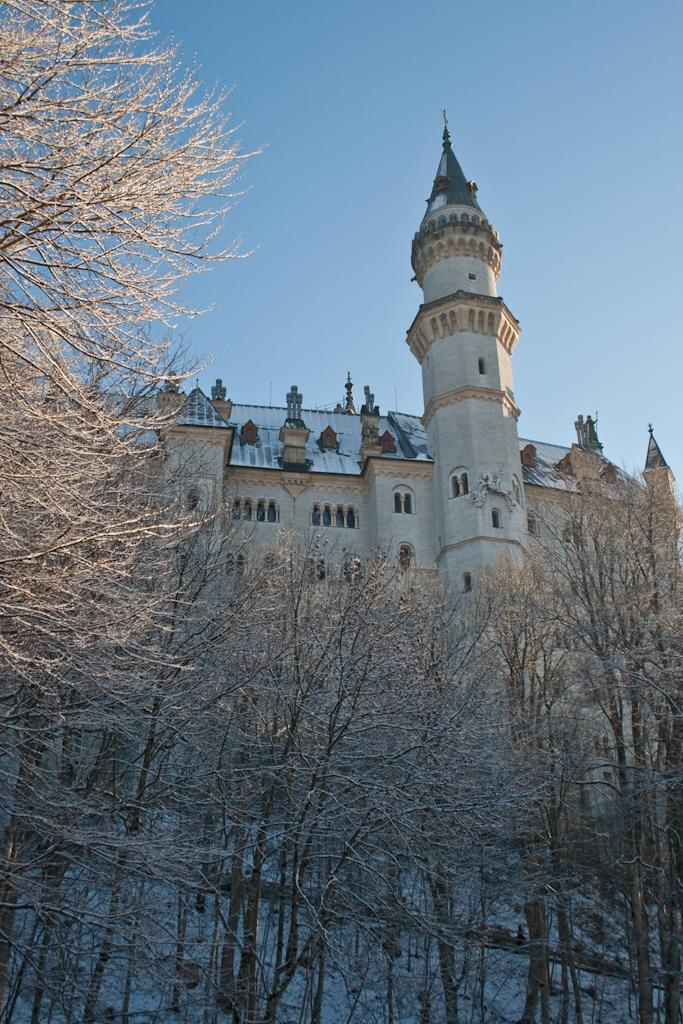What type of vegetation can be seen in the image? There are trees in the image. What type of structure is present in the image? There is a building in the image. What is the weather like in the image? Snow is present in the image, indicating a cold or wintry environment. What is visible in the background of the image? The sky is visible in the image. Can you see any horns on the trees in the image? There are no horns present on the trees in the image. Is the building in the image located in space? The image does not depict a location in space; it shows a building on Earth with trees, snow, and sky. 